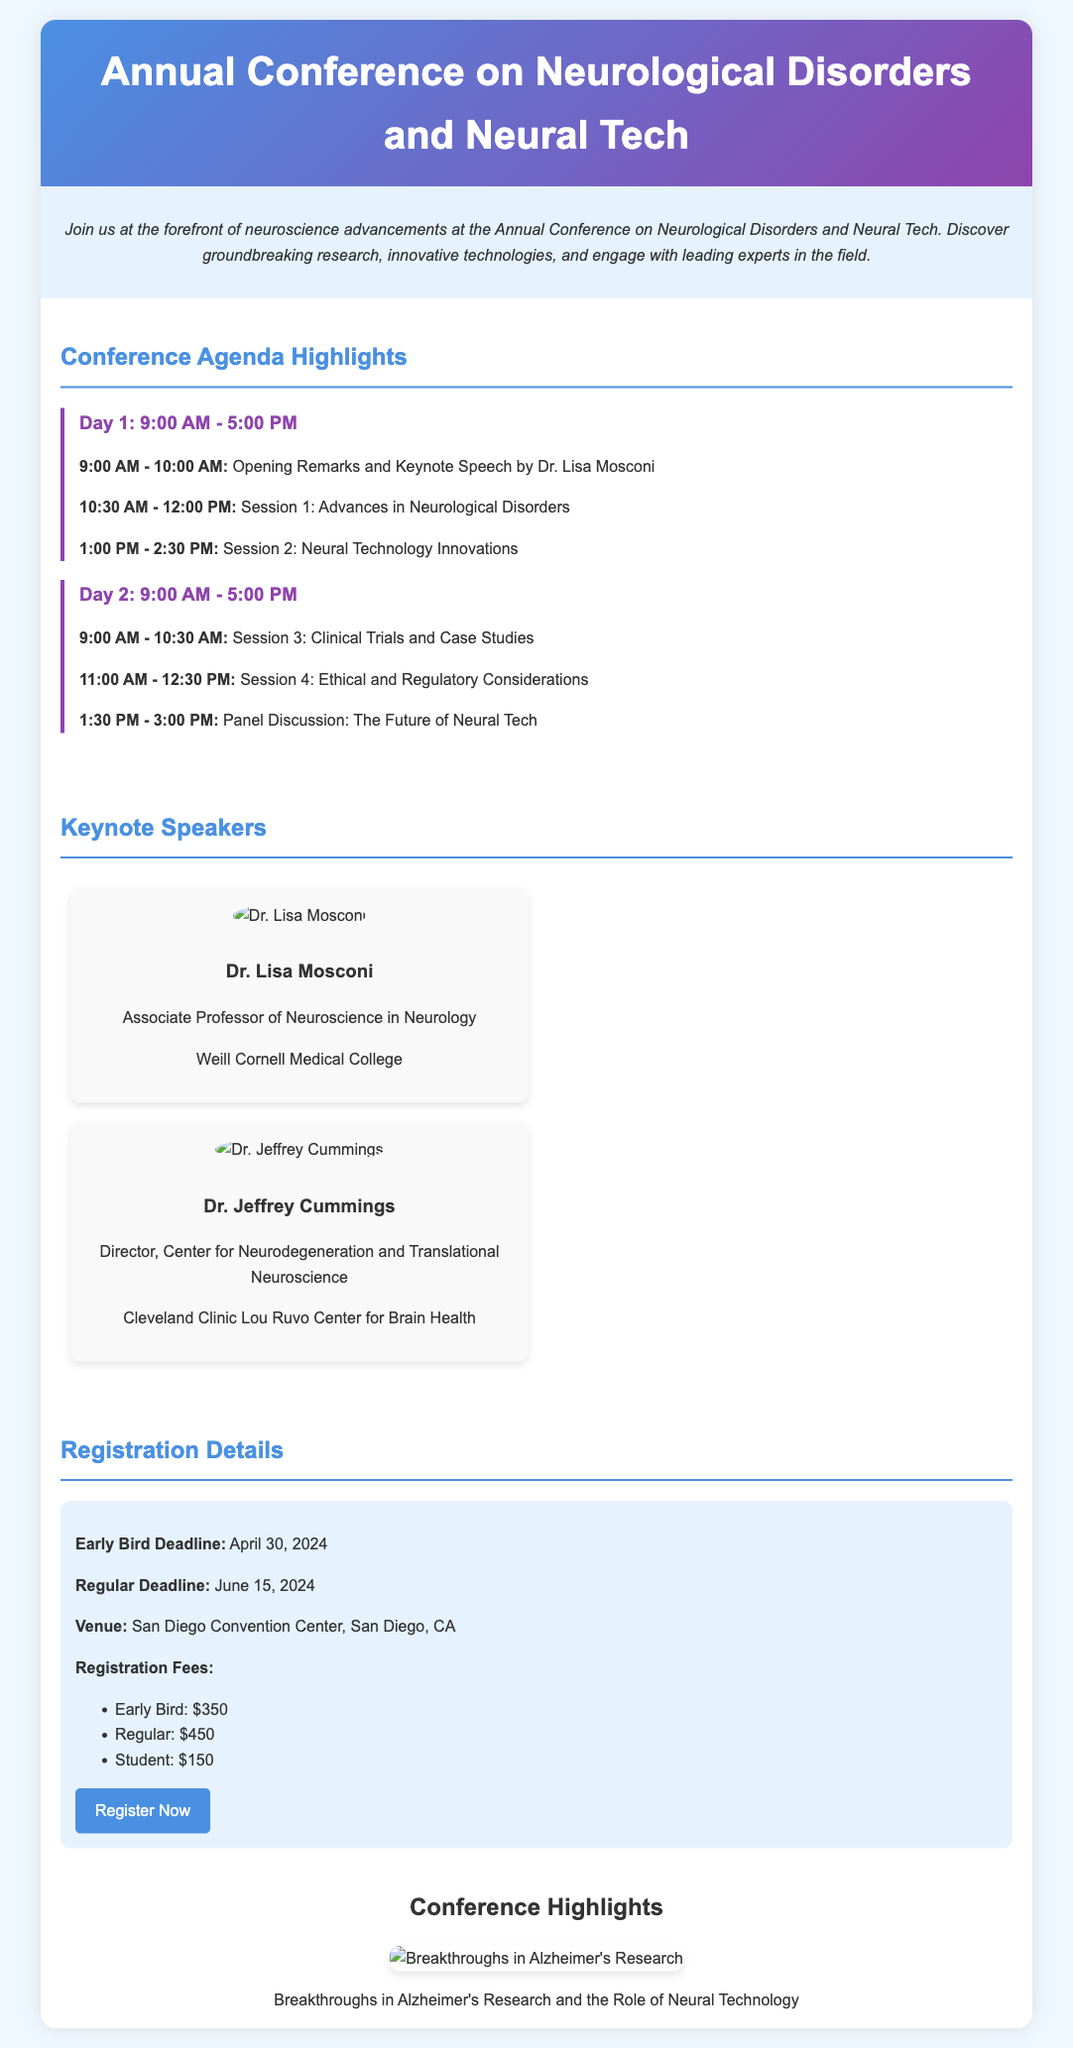What is the conference title? The title of the conference is prominently displayed at the top of the flyer.
Answer: Annual Conference on Neurological Disorders and Neural Tech Who is the keynote speaker on Day 1? The keynote speaker is mentioned in the agenda for Day 1.
Answer: Dr. Lisa Mosconi What is the venue of the conference? The venue is noted in the registration details section.
Answer: San Diego Convention Center, San Diego, CA What is the early bird registration fee? The early bird registration fee is listed in the registration details.
Answer: $350 What session topic occurs after the keynote speech? The session following the keynote speech is specified in the agenda.
Answer: Advances in Neurological Disorders How many days is the conference scheduled for? The agenda section lays out the schedule over two days.
Answer: 2 days What is the regular registration deadline? The regular registration deadline can be found in the registration details.
Answer: June 15, 2024 Who is the second keynote speaker listed? The second keynote speaker is highlighted in the speakers section.
Answer: Dr. Jeffrey Cummings What infographic is included in the conference highlights? The infographic is mentioned in the conference highlights section.
Answer: Breakthroughs in Alzheimer's Research and the Role of Neural Technology 